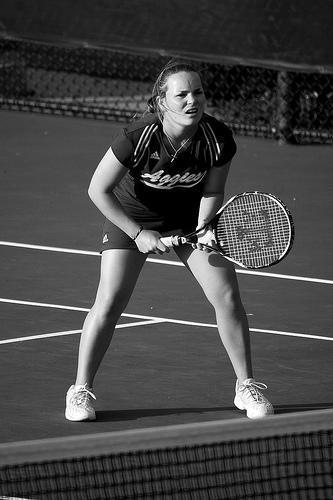How many girls are in the photo?
Give a very brief answer. 1. 